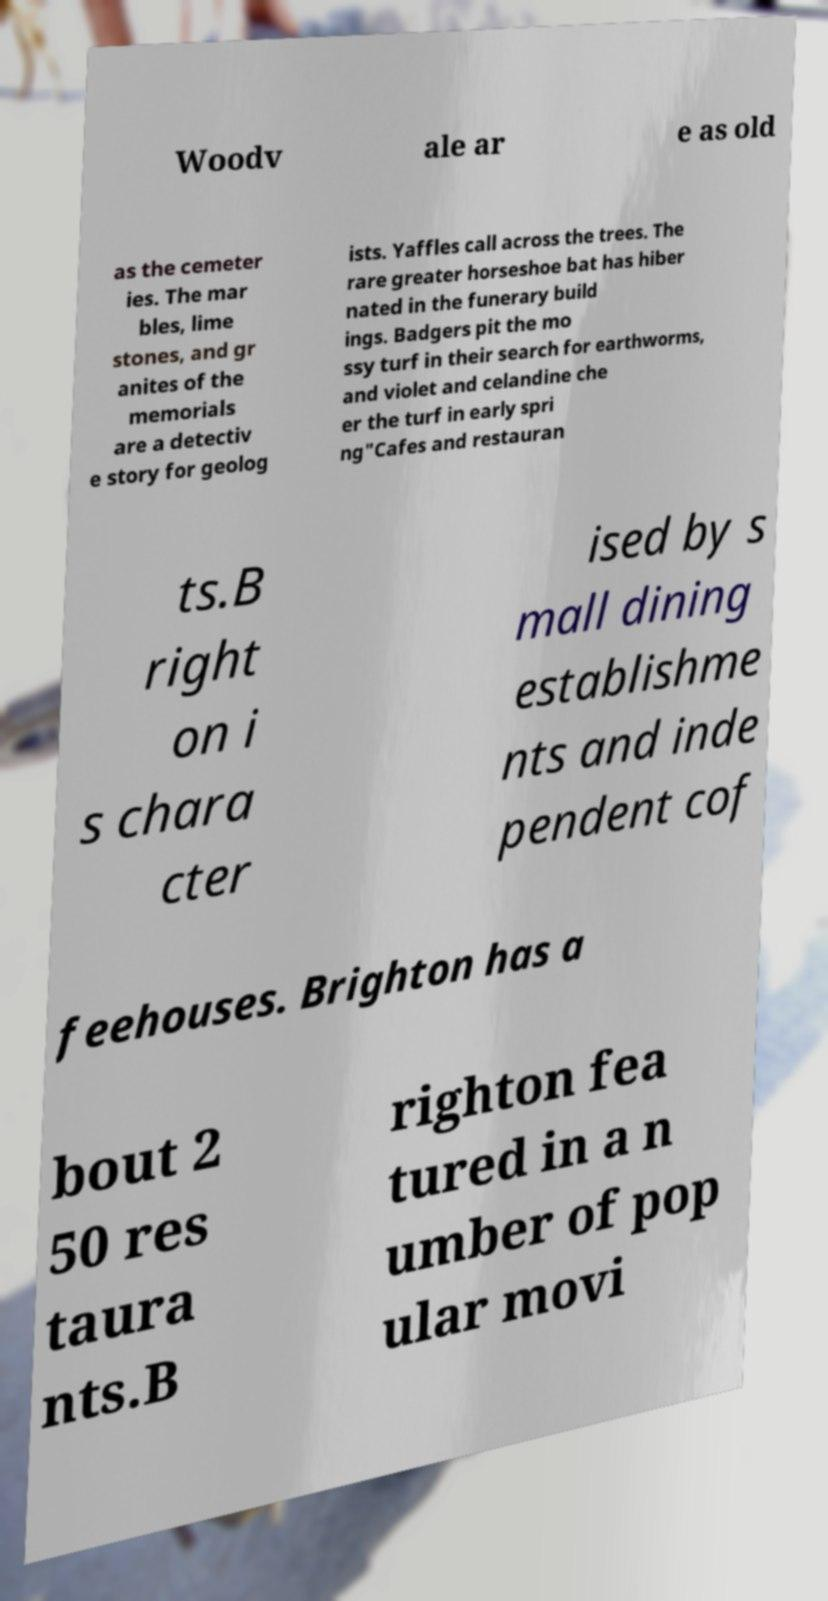For documentation purposes, I need the text within this image transcribed. Could you provide that? Woodv ale ar e as old as the cemeter ies. The mar bles, lime stones, and gr anites of the memorials are a detectiv e story for geolog ists. Yaffles call across the trees. The rare greater horseshoe bat has hiber nated in the funerary build ings. Badgers pit the mo ssy turf in their search for earthworms, and violet and celandine che er the turf in early spri ng"Cafes and restauran ts.B right on i s chara cter ised by s mall dining establishme nts and inde pendent cof feehouses. Brighton has a bout 2 50 res taura nts.B righton fea tured in a n umber of pop ular movi 